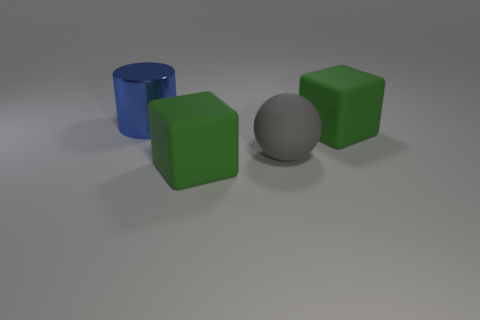What material is the large gray ball?
Keep it short and to the point. Rubber. How many large green matte cubes are in front of the large gray sphere?
Your response must be concise. 1. Is there a green thing of the same size as the blue cylinder?
Provide a succinct answer. Yes. How many big objects have the same color as the big shiny cylinder?
Offer a terse response. 0. What number of things are large yellow rubber blocks or blue metal objects that are to the left of the gray rubber ball?
Offer a terse response. 1. What is the size of the green object that is in front of the green cube on the right side of the gray matte thing?
Make the answer very short. Large. Is the number of cylinders in front of the big gray matte ball the same as the number of large blocks in front of the blue shiny object?
Your response must be concise. No. Is there a green matte cube in front of the large matte block that is to the right of the big rubber sphere?
Keep it short and to the point. Yes. Is there anything else that has the same color as the large rubber sphere?
Offer a very short reply. No. The thing that is behind the big green thing behind the gray matte thing is made of what material?
Ensure brevity in your answer.  Metal. 